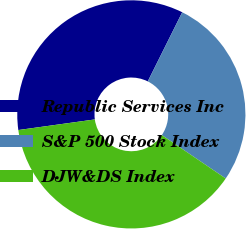Convert chart. <chart><loc_0><loc_0><loc_500><loc_500><pie_chart><fcel>Republic Services Inc<fcel>S&P 500 Stock Index<fcel>DJW&DS Index<nl><fcel>34.55%<fcel>27.14%<fcel>38.31%<nl></chart> 